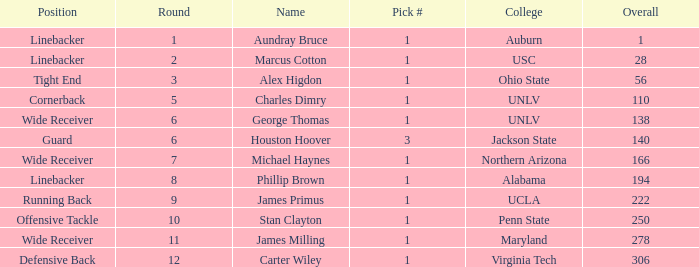What is Aundray Bruce's Pick #? 1.0. 